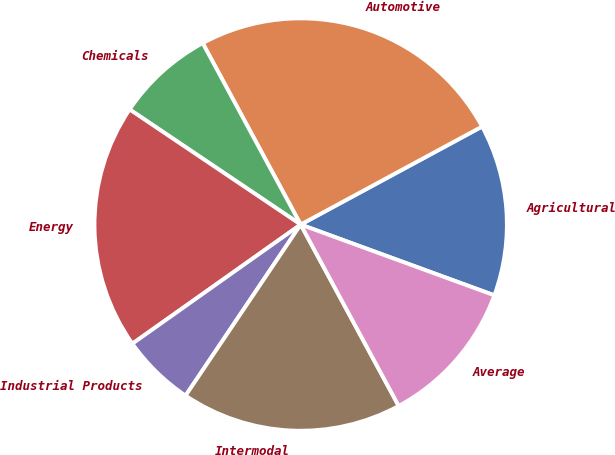Convert chart to OTSL. <chart><loc_0><loc_0><loc_500><loc_500><pie_chart><fcel>Agricultural<fcel>Automotive<fcel>Chemicals<fcel>Energy<fcel>Industrial Products<fcel>Intermodal<fcel>Average<nl><fcel>13.46%<fcel>25.0%<fcel>7.69%<fcel>19.23%<fcel>5.77%<fcel>17.31%<fcel>11.54%<nl></chart> 